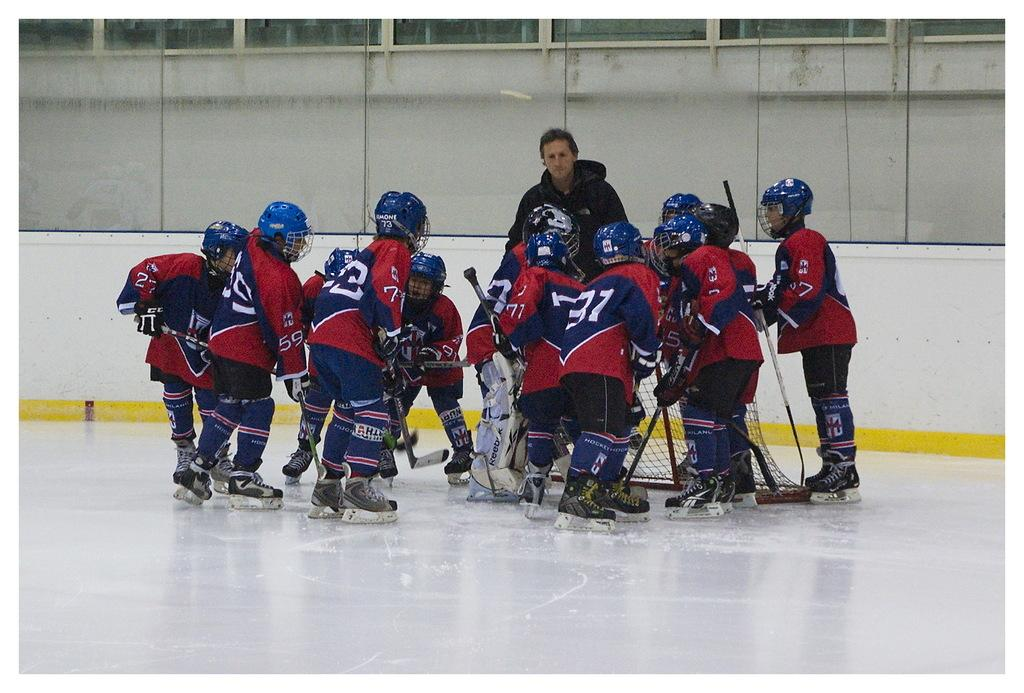How many people are in the image? There is a group of persons in the image, but the exact number is not specified. What are the persons doing in the image? The persons are playing on a white surface. What can be seen in the background of the image? There is a wall visible in the background of the image. What type of cake is being served to the persons in the image? There is no cake present in the image; the persons are playing on a white surface. Do the persons have fangs in the image? There is no indication of fangs or any other unusual features on the persons in the image. 